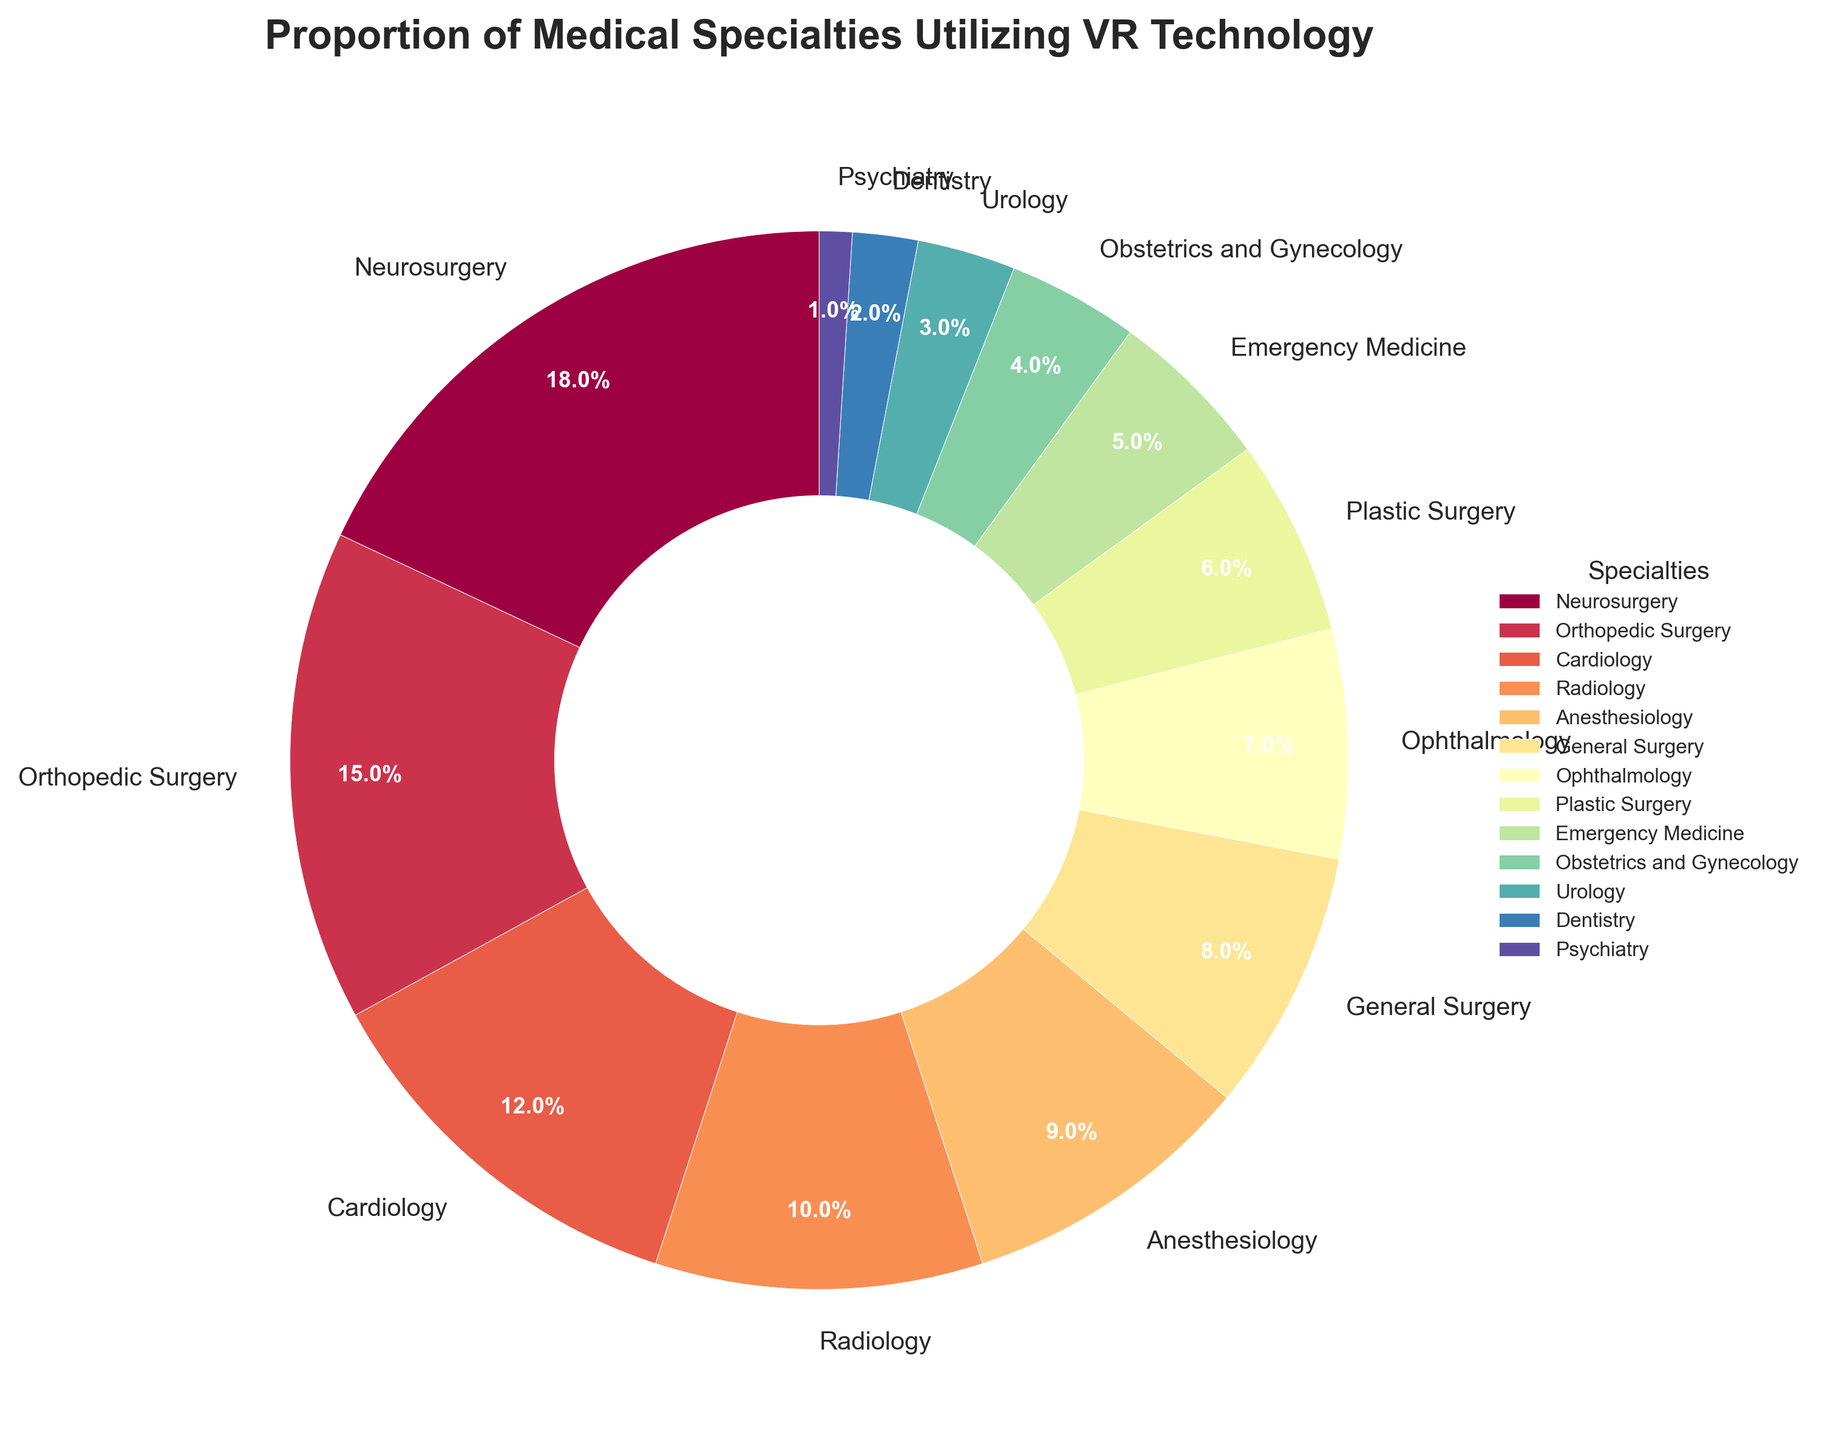What's the largest proportion of a single medical specialty using VR technology? By examining the pie chart, you can observe that the wedge corresponding to Neurosurgery has the largest size and percentage label.
Answer: 18% Which specialty has a percentage of use that is exactly half of Neurosurgery's? Neurosurgery uses VR technology at 18%, so half of that is 9%. Anesthesiology is listed with a 9% usage, which matches this value.
Answer: Anesthesiology Compare the use of VR technology in Cardiology and Radiology. Which utilizes it more, and by how much? On the pie chart, Cardiology shows a percentage of 12%, and Radiology shows 10%. Subtracting the two gives the difference.
Answer: Cardiology by 2% What's the combined percentage of the three specialties with the smallest utilization of VR technology? Psychiatry (1%), Dentistry (2%), and Urology (3%) are the smallest. Adding these percentages together (1% + 2% + 3%) gives the combined total.
Answer: 6% Among General Surgery and Orthopedic Surgery, which one utilizes VR technology more? General Surgery has an 8% usage, while Orthopedic Surgery has a 15% usage. By comparison, Orthopedic Surgery has a higher percentage.
Answer: Orthopedic Surgery Are there more specialties utilizing VR technology less than 10% or more than 10%? To answer this, count the specialties falling below and above the 10% mark respectively. Below 10%: Anesthesiology, General Surgery, Ophthalmology, Plastic Surgery, Emergency Medicine, Obstetrics and Gynecology, Urology, Dentistry, Psychiatry (total 9). Above 10%: Neurosurgery, Orthopedic Surgery, Cardiology, Radiology (total 4).
Answer: Less than 10% What's the average percentage utilization of VR technology across Neurology, Orthopedic Surgery, and Cardiology? Sum the percentages for Neurosurgery (18%), Orthopedic Surgery (15%), and Cardiology (12%) to get 45%. Then divide by 3 (45/3).
Answer: 15% If you were to combine the percentages of Emergency Medicine and Obstetrics and Gynecology, would the total surpass General Surgery's percentage? Emergency Medicine is at 5% and Obstetrics and Gynecology is at 4%. Adding these gives 9%, which surpasses General Surgery's 8%.
Answer: Yes Which specialty falls right in the middle rank-wise concerning its utilization of VR technology? The middle rank can be found by arranging all percentages in ascending order (1, 2, 3, 4, 5, 6, 7, 8, 9, 10, 12, 15, 18). The middle value of this 13-element list is the 7th value, which is Ophthalmology at 7%.
Answer: Ophthalmology 